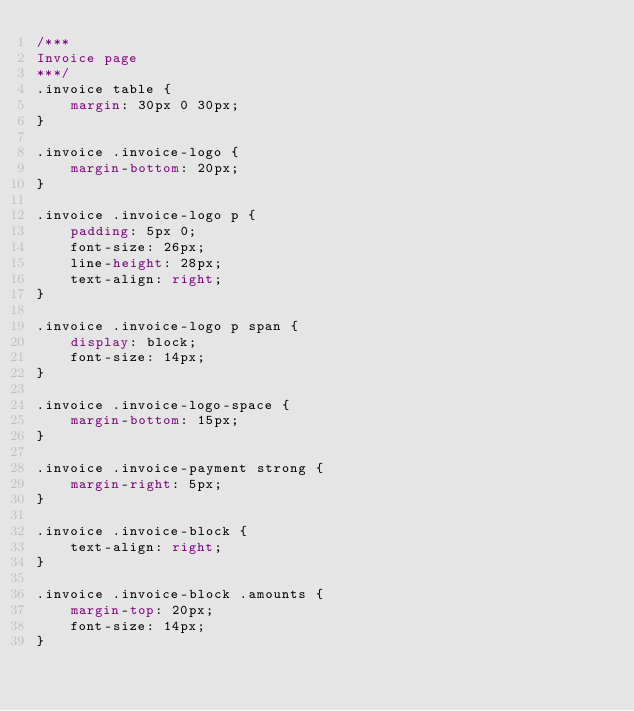Convert code to text. <code><loc_0><loc_0><loc_500><loc_500><_CSS_>/***
Invoice page
***/
.invoice table {
    margin: 30px 0 30px;
}

.invoice .invoice-logo {
    margin-bottom: 20px;
}

.invoice .invoice-logo p {
    padding: 5px 0;
    font-size: 26px;
    line-height: 28px;
    text-align: right;
}

.invoice .invoice-logo p span {
    display: block;
    font-size: 14px;
}

.invoice .invoice-logo-space {
    margin-bottom: 15px;
}

.invoice .invoice-payment strong {
    margin-right: 5px;
}

.invoice .invoice-block {
    text-align: right;
}

.invoice .invoice-block .amounts {
    margin-top: 20px;
    font-size: 14px;
}</code> 